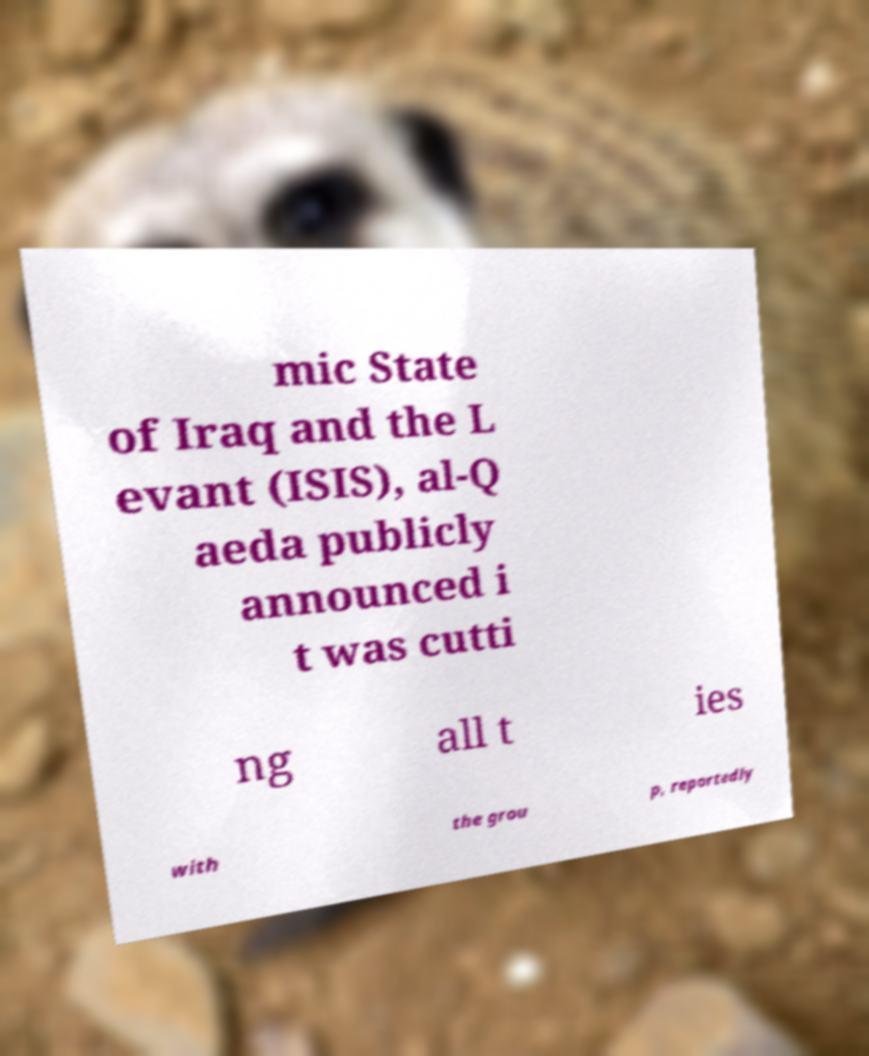I need the written content from this picture converted into text. Can you do that? mic State of Iraq and the L evant (ISIS), al-Q aeda publicly announced i t was cutti ng all t ies with the grou p, reportedly 